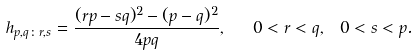Convert formula to latex. <formula><loc_0><loc_0><loc_500><loc_500>h _ { p , q \colon r , s } = \frac { ( r p - s q ) ^ { 2 } - ( p - q ) ^ { 2 } } { 4 p q } , \ \ 0 < r < q , \ 0 < s < p .</formula> 